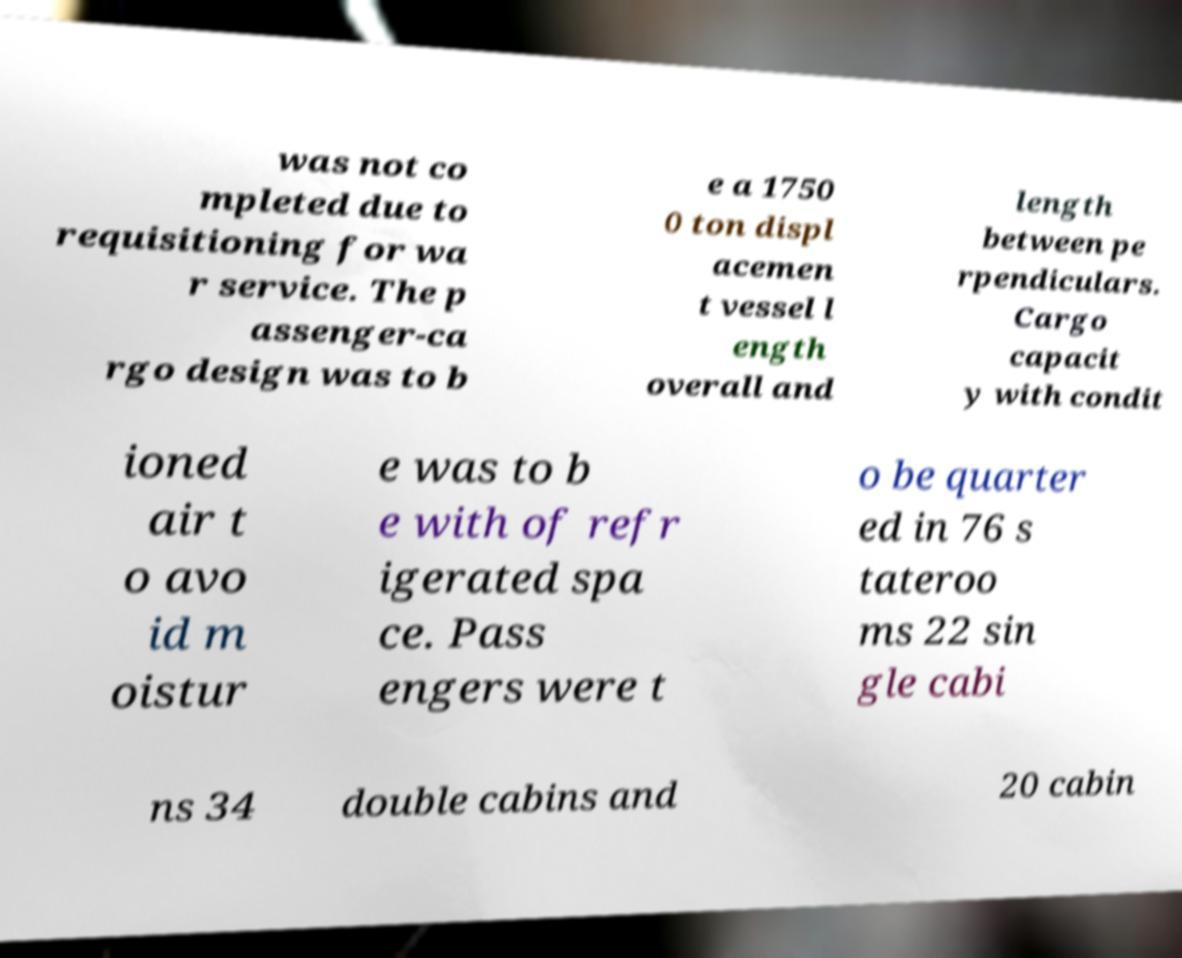Could you assist in decoding the text presented in this image and type it out clearly? was not co mpleted due to requisitioning for wa r service. The p assenger-ca rgo design was to b e a 1750 0 ton displ acemen t vessel l ength overall and length between pe rpendiculars. Cargo capacit y with condit ioned air t o avo id m oistur e was to b e with of refr igerated spa ce. Pass engers were t o be quarter ed in 76 s tateroo ms 22 sin gle cabi ns 34 double cabins and 20 cabin 